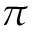<formula> <loc_0><loc_0><loc_500><loc_500>\pi</formula> 